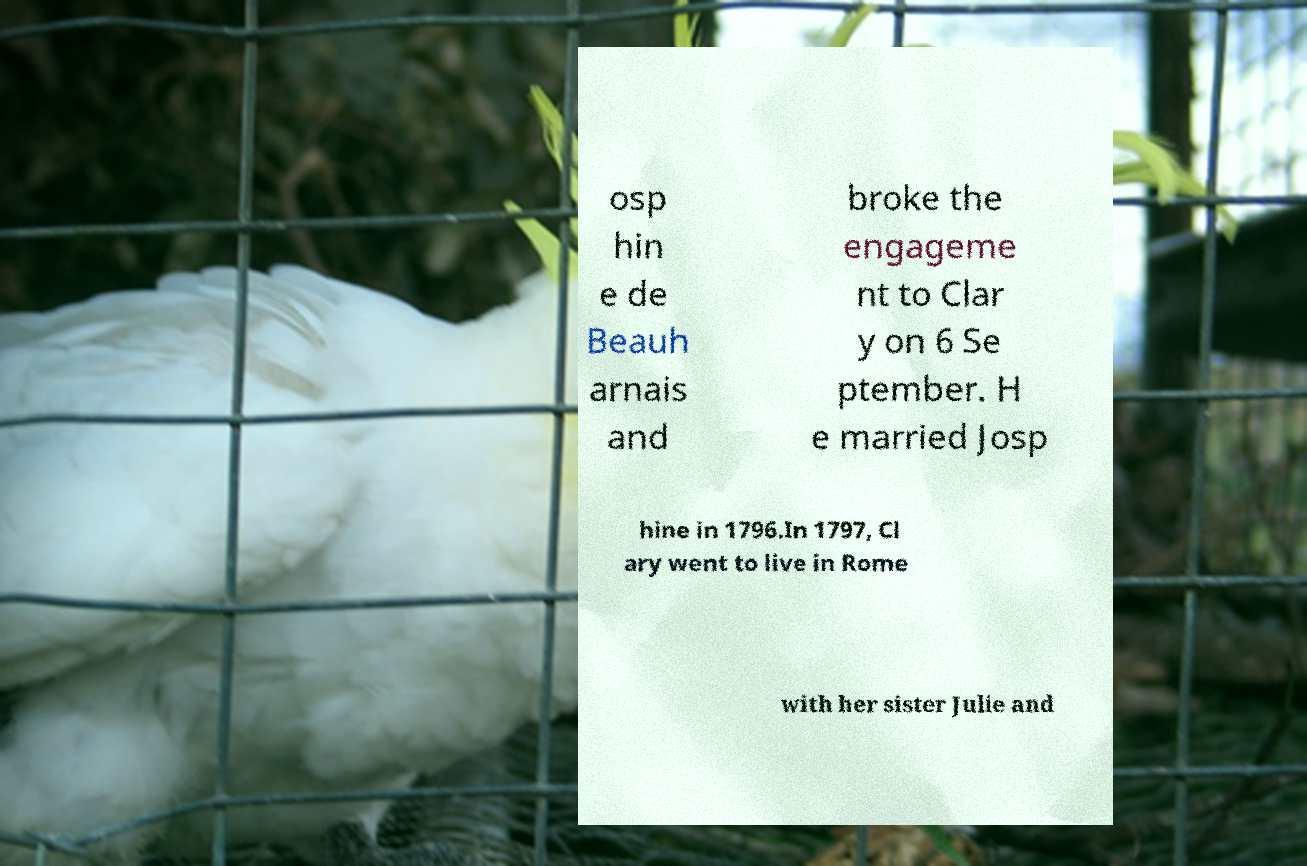For documentation purposes, I need the text within this image transcribed. Could you provide that? osp hin e de Beauh arnais and broke the engageme nt to Clar y on 6 Se ptember. H e married Josp hine in 1796.In 1797, Cl ary went to live in Rome with her sister Julie and 